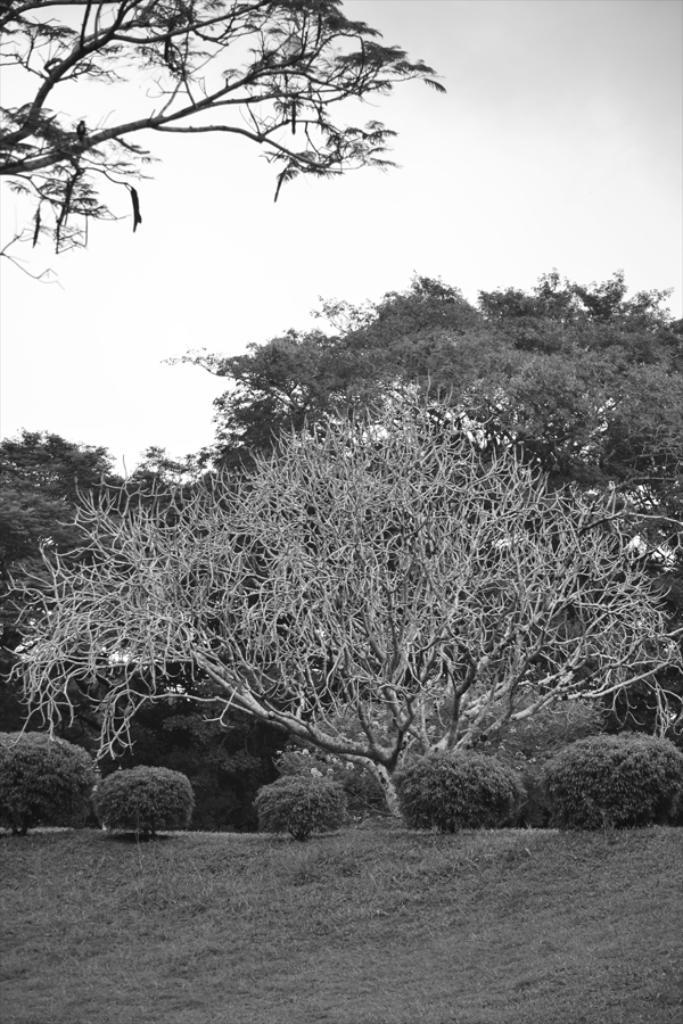What type of vegetation can be seen in the image? There is grass, plants, and trees in the image. What is visible at the top of the image? The sky is visible at the top of the image. What type of crate is being used to tell a story in the image? There is no crate or storytelling depicted in the image; it features grass, plants, and trees as the main subjects. Then, we mention the sky's visibility at the top of the image. The absurd question is introduced, asking about a crate and storytelling, which are not present in the image. 